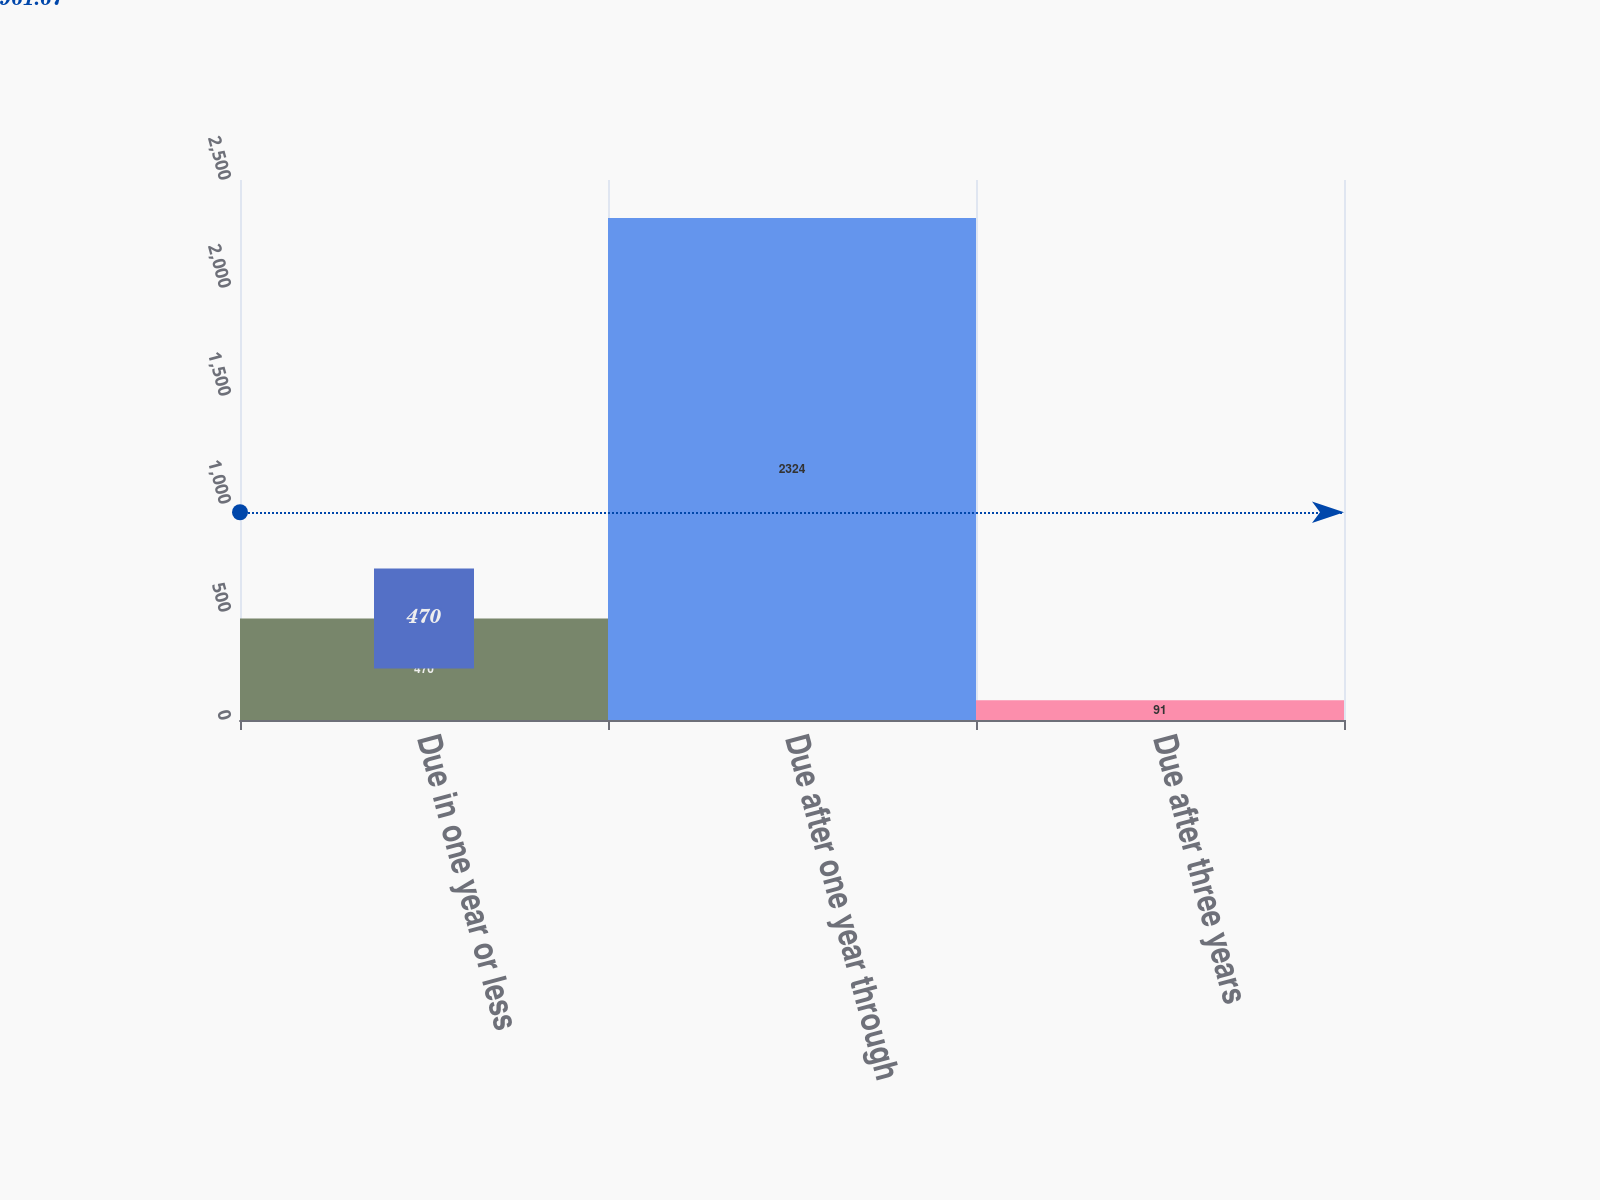<chart> <loc_0><loc_0><loc_500><loc_500><bar_chart><fcel>Due in one year or less<fcel>Due after one year through<fcel>Due after three years<nl><fcel>470<fcel>2324<fcel>91<nl></chart> 